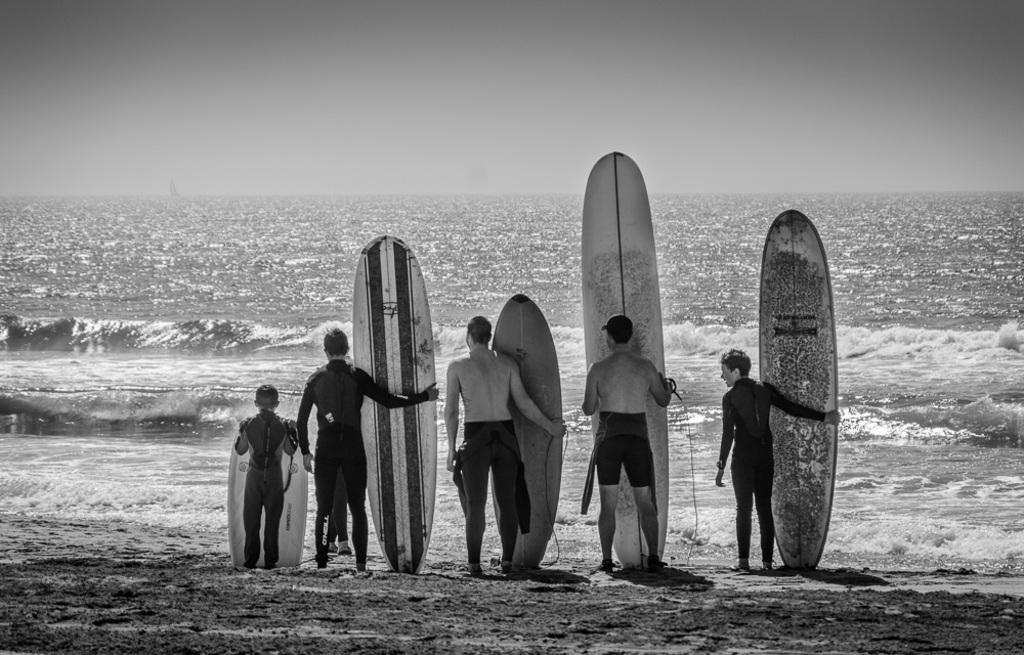How many people are in the image? There is a group of persons in the image. Where are the persons located in the image? The persons are standing on the beach. What are the persons holding in the image? The persons are holding surfing boards. What can be seen in the background of the image? There is an ocean visible in the background of the image. What type of print can be seen on the chalk in the image? There is no print or chalk present in the image. 